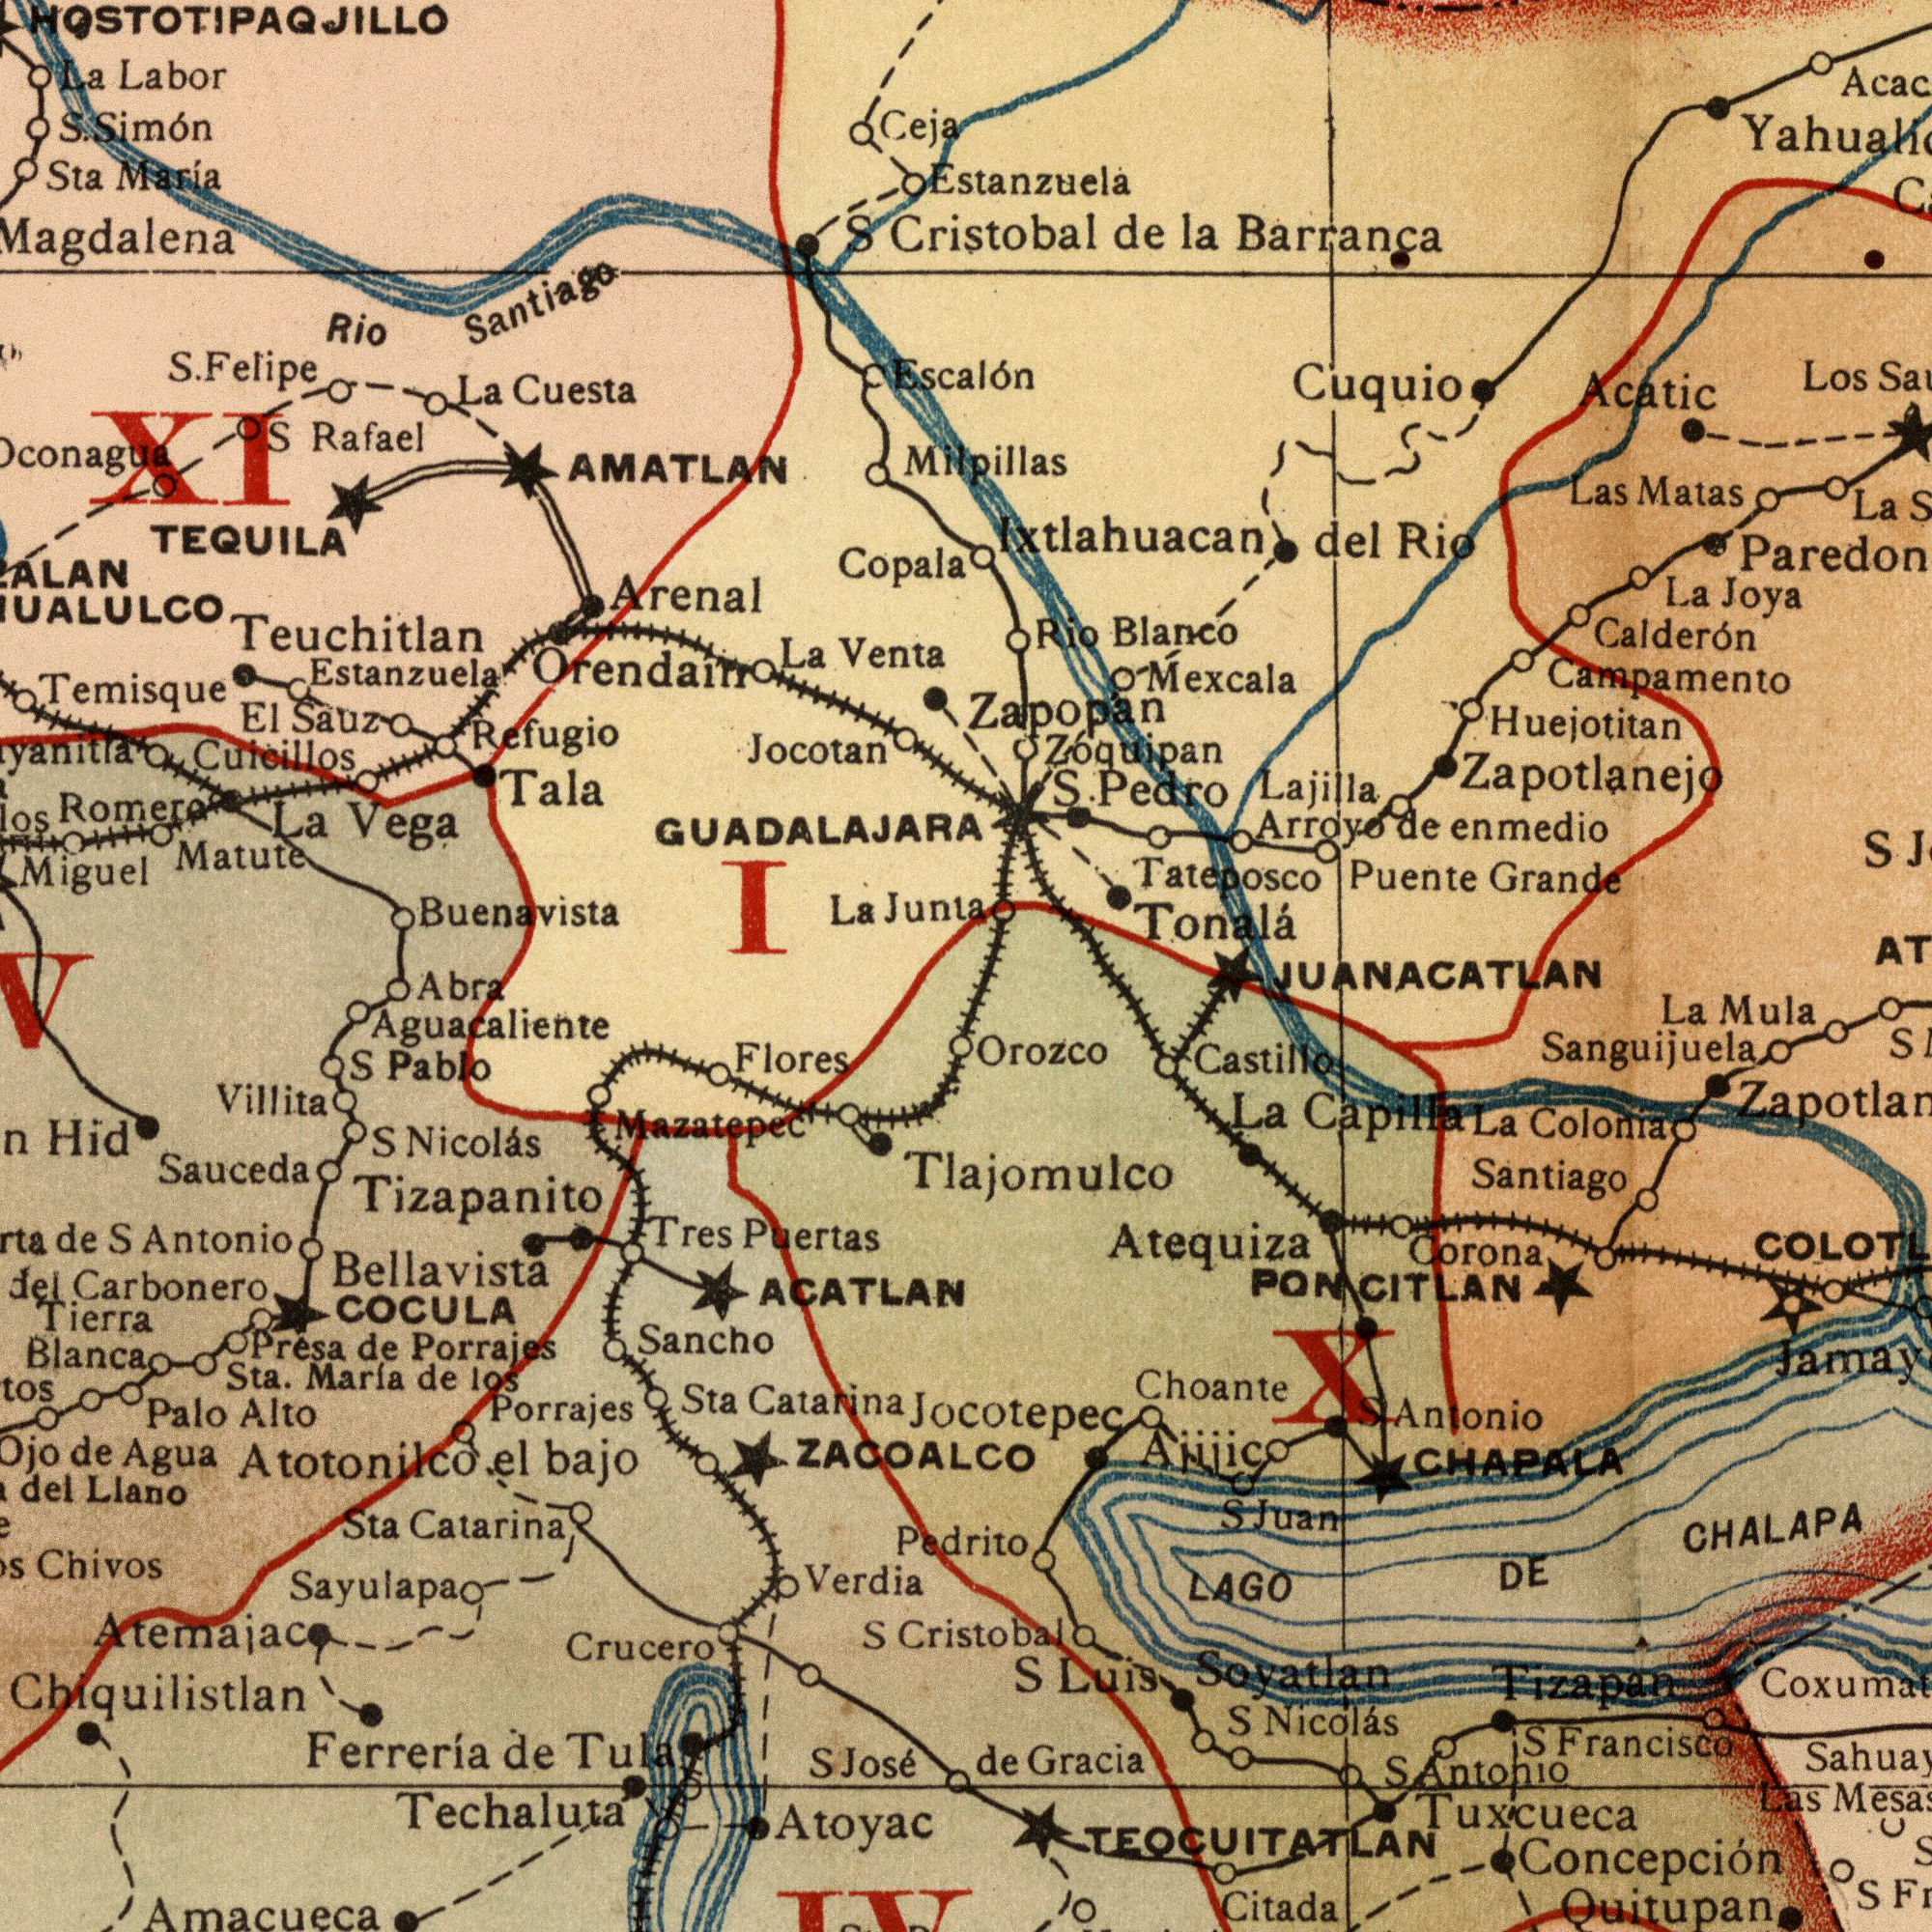What text is shown in the bottom-right quadrant? Cristobal Sanguijuela CHAPALA CHALAPA Soyatlan Orozco Choante Citada Francisco Santiago Quitupan Atequiza Corona Nicolás Gracia Castillo LAGO Mula Antonio Colonia Las La de Luis Tlajomulco Concepción DE Jocotepec Juan Antonio La S Tizapan S S CITLAN Capilla TEOCUITATLAN Tuxcueca La Ajijic S JUANACATLAN PON X S S S What text appears in the top-left area of the image? Buenavista Cuicillos Estanzuela Arenal AMATLAN Miguel Jocotan Matute Refugio Labor Temisque ###conagua Santiago Maria Tala Romero Magdalena Rafael Sta Vega Venta La Copala La La Escalón Sauz Cuesta Simón Orendain Rio Felipe I GUADALAJARA S. El S. S Junia TEQUILA Teuchitlan La S La Ceja HOSTOTIPAQJILLO XI What text is shown in the bottom-left quadrant? Carbonero Techaluta Mazatepec Sancho Aguacaliente Flores Blanca Sauceda Porrajes Tierra Marla Chivos Crucero Verdia ACATLAN Sta Tizapanito Hid ZACOALCO Ferrería Atemajac Porrajes Atoyac Nicolás Sta Pablo COCULA Presa Tres Palo S Alto Antonio Agua del Villita Sta. Chiquilistlan Llano Abra Pedrito Tula de de los bajo José de Puertas Catarina del Amacueca de Catarina S S de S S Sayulapa Bellavista Atotonilco el What text appears in the top-right area of the image? Tateposco Calderón Estanzuela Paredon Acatic Tonalá Cristobal Puente Las Lajilla enmedio Mexcala Joya Los Ixtlahuacan Zapopan Zoquipan Rio Pedro Cuquio Milpillas del La Matas Campamento S. Zapotlanejo Blanco Rio La Grande Huejotitan la de Barranca Arroyo de 